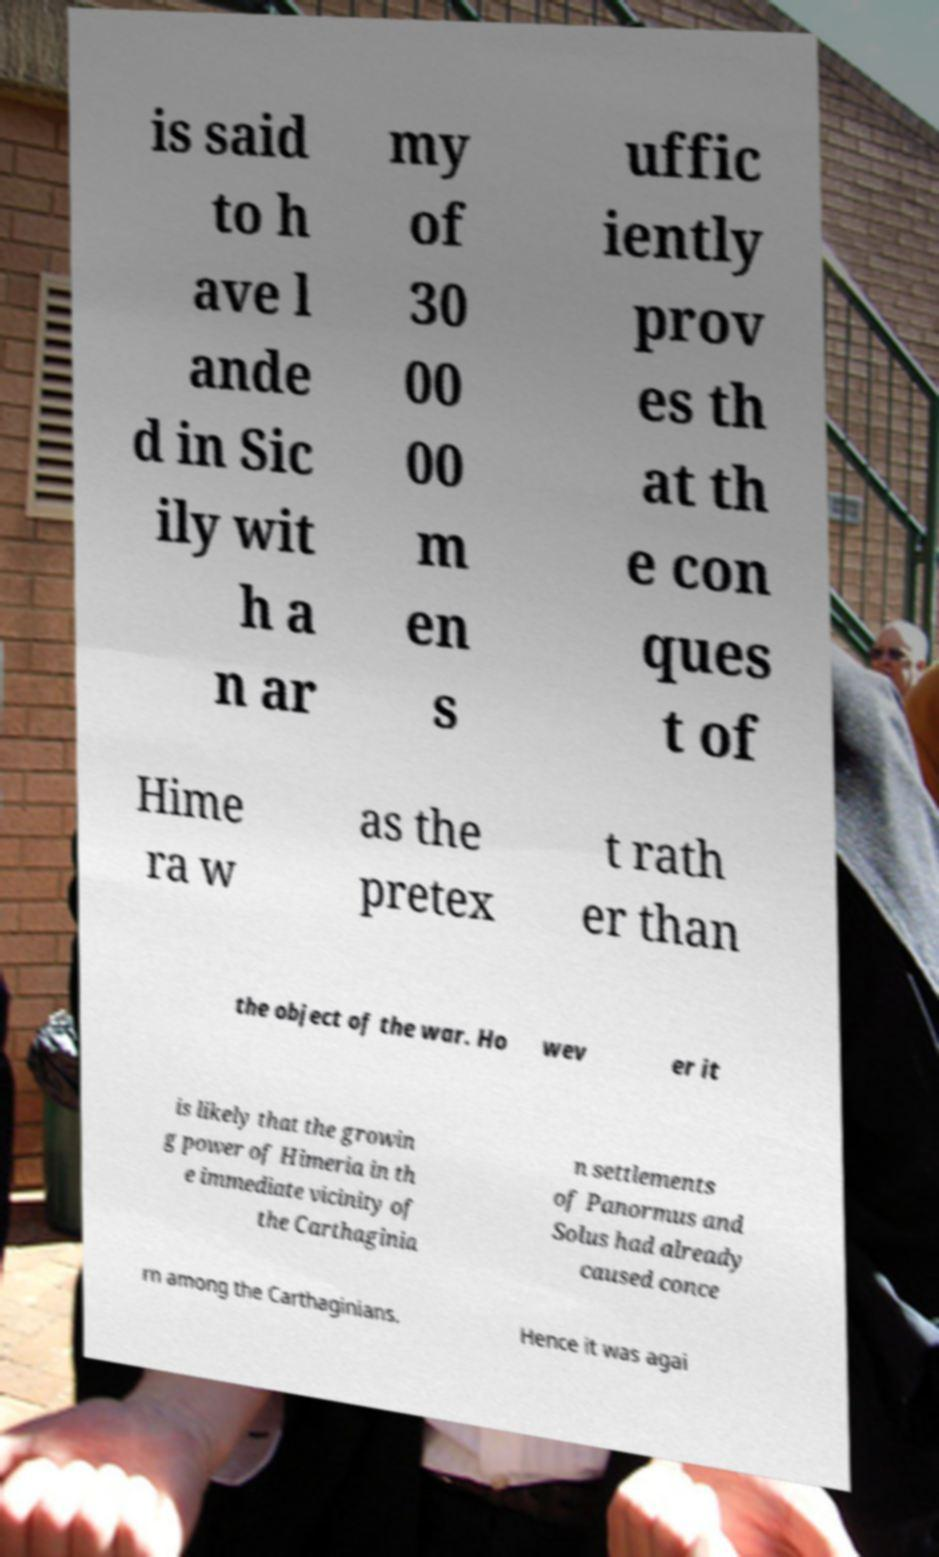Can you read and provide the text displayed in the image?This photo seems to have some interesting text. Can you extract and type it out for me? is said to h ave l ande d in Sic ily wit h a n ar my of 30 00 00 m en s uffic iently prov es th at th e con ques t of Hime ra w as the pretex t rath er than the object of the war. Ho wev er it is likely that the growin g power of Himeria in th e immediate vicinity of the Carthaginia n settlements of Panormus and Solus had already caused conce rn among the Carthaginians. Hence it was agai 